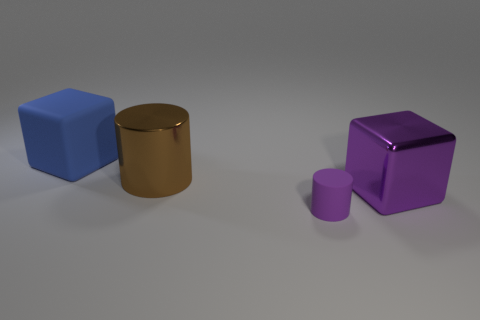Add 3 blue things. How many objects exist? 7 Add 3 matte blocks. How many matte blocks are left? 4 Add 1 metal balls. How many metal balls exist? 1 Subtract 0 gray blocks. How many objects are left? 4 Subtract all big blue things. Subtract all brown metal cylinders. How many objects are left? 2 